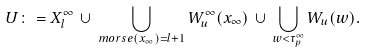Convert formula to latex. <formula><loc_0><loc_0><loc_500><loc_500>U \colon = X ^ { \infty } _ { l } \, \cup \, \bigcup _ { m o r s e ( x { _ { \infty } } ) = l + 1 } W ^ { \infty } _ { u } ( x _ { \infty } ) \, \cup \, \bigcup _ { w < \tau _ { p } ^ { \infty } } W _ { u } ( w ) .</formula> 